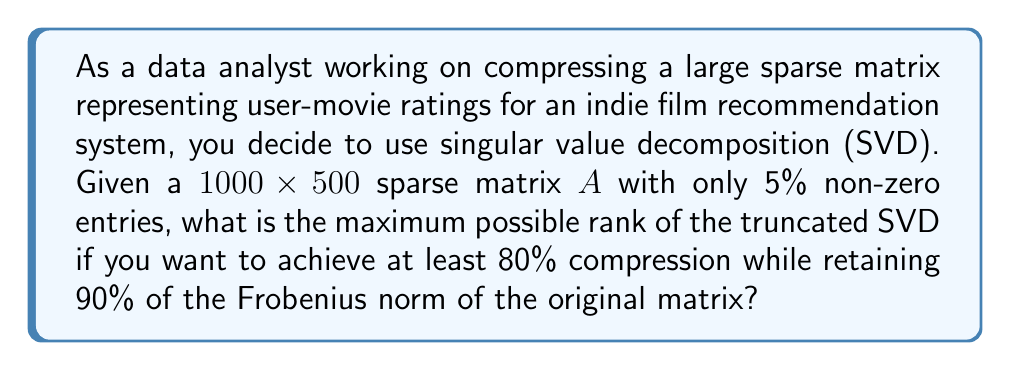Can you answer this question? Let's approach this step-by-step:

1) First, recall that for a matrix $A \in \mathbb{R}^{m \times n}$, its SVD is given by:

   $A = U\Sigma V^T$

   where $U \in \mathbb{R}^{m \times m}$, $\Sigma \in \mathbb{R}^{m \times n}$, and $V \in \mathbb{R}^{n \times n}$.

2) The rank of the truncated SVD will be $k$, where $k < \min(m,n)$. We need to find the maximum possible $k$.

3) In this case, $m = 1000$ and $n = 500$.

4) The original matrix has $1000 \times 500 = 500,000$ entries, but only 5% are non-zero. So there are $25,000$ non-zero entries.

5) For a rank-$k$ truncated SVD, we need to store:
   - $k$ columns of $U$: $1000k$ entries
   - $k$ singular values: $k$ entries
   - $k$ columns of $V$: $500k$ entries
   Total: $1501k$ entries

6) For 80% compression, we need:

   $1501k \leq 25,000 \times 0.2 = 5,000$

7) Solving this inequality:

   $k \leq 5,000 / 1501 \approx 3.33$

8) Now, we need to check if this satisfies the 90% Frobenius norm retention. The Frobenius norm retention is given by:

   $\frac{\sum_{i=1}^k \sigma_i^2}{\sum_{i=1}^r \sigma_i^2} \geq 0.9$

   where $r$ is the rank of $A$ and $\sigma_i$ are the singular values.

9) Without knowing the actual singular values, we can't verify this condition. However, for sparse matrices, it's often possible to achieve high norm retention with a low-rank approximation.

10) Given the constraints, the maximum possible rank that satisfies the compression requirement is 3.
Answer: 3 